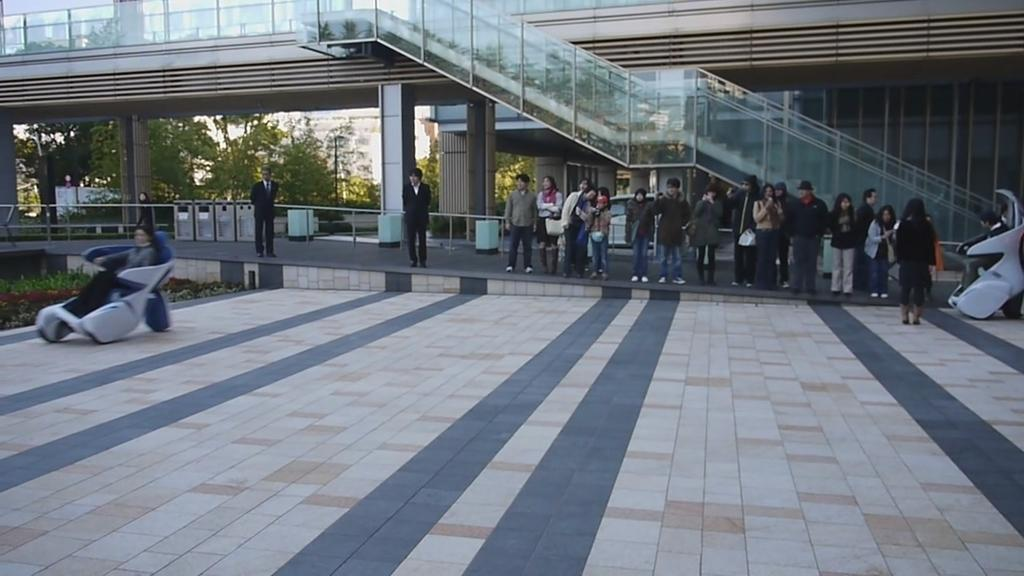What is happening in the image? There is a group of people standing in the image. What can be seen in the background of the image? There are stairs, buildings in cream and white color, and trees in green color visible in the background of the image. How many kittens are sitting on the stairs in the image? There are no kittens present in the image; only a group of people and background elements are visible. 